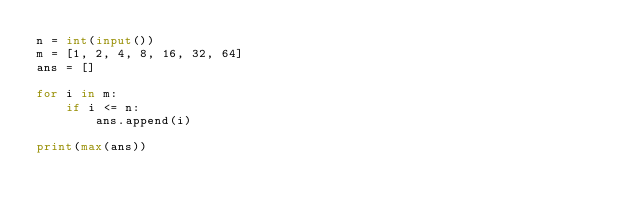<code> <loc_0><loc_0><loc_500><loc_500><_Python_>n = int(input())
m = [1, 2, 4, 8, 16, 32, 64]
ans = []

for i in m:
    if i <= n:
        ans.append(i)

print(max(ans))</code> 